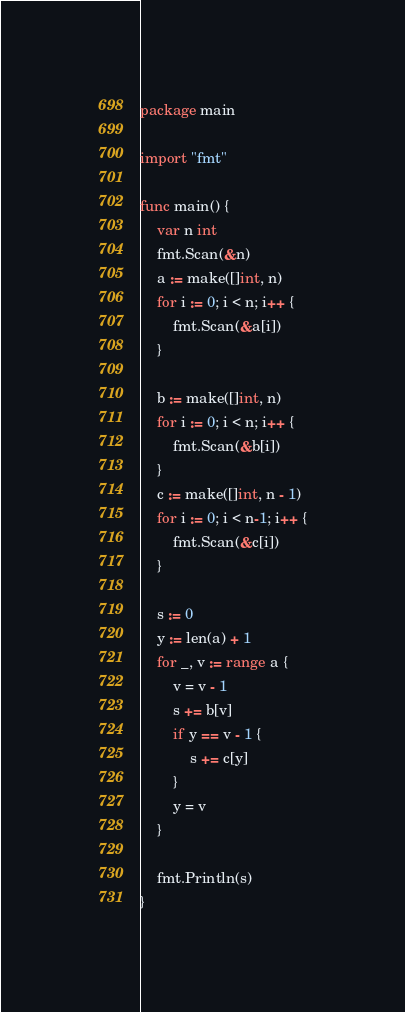Convert code to text. <code><loc_0><loc_0><loc_500><loc_500><_Go_>package main

import "fmt"

func main() {
	var n int
	fmt.Scan(&n)
	a := make([]int, n)
	for i := 0; i < n; i++ {
		fmt.Scan(&a[i])
	}

	b := make([]int, n)
	for i := 0; i < n; i++ {
		fmt.Scan(&b[i])
	}
	c := make([]int, n - 1)
	for i := 0; i < n-1; i++ {
		fmt.Scan(&c[i])
	}

	s := 0
	y := len(a) + 1
	for _, v := range a {
		v = v - 1
		s += b[v]
		if y == v - 1 {
			s += c[y]
		}
		y = v
	}

	fmt.Println(s)
}
</code> 